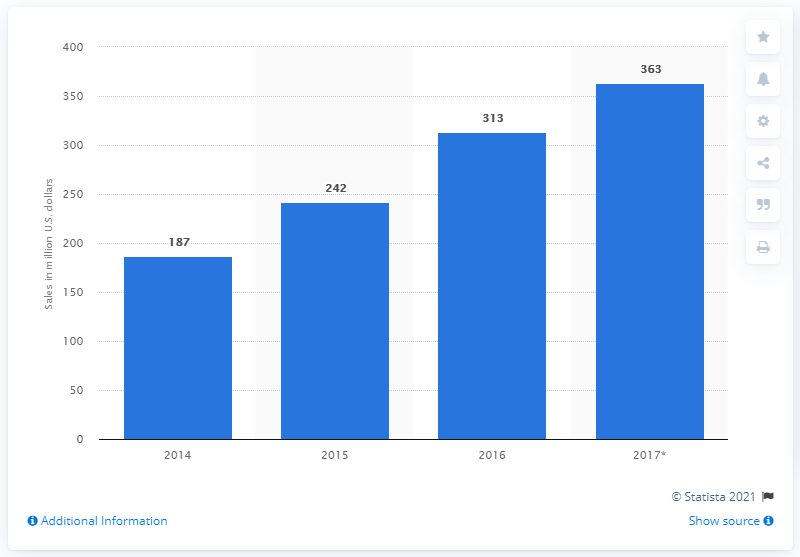Outline some significant characteristics in this image. In 2016, the revenue from connected thermostat sales in the United States was approximately 313 million U.S. dollars. 